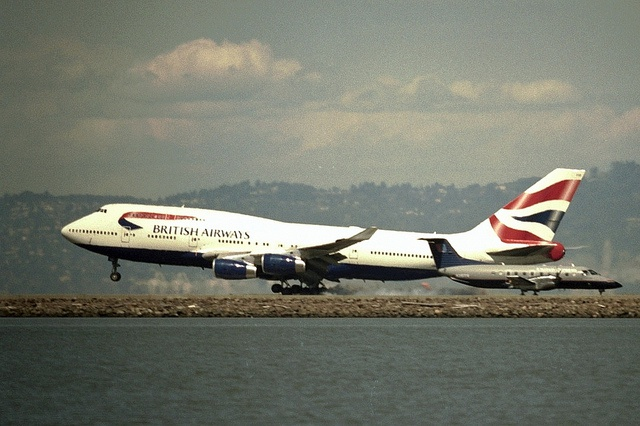Describe the objects in this image and their specific colors. I can see airplane in gray, ivory, black, and beige tones and airplane in gray, black, and darkgray tones in this image. 